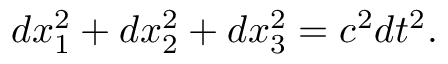<formula> <loc_0><loc_0><loc_500><loc_500>d x _ { 1 } ^ { 2 } + d x _ { 2 } ^ { 2 } + d x _ { 3 } ^ { 2 } = c ^ { 2 } d t ^ { 2 } .</formula> 